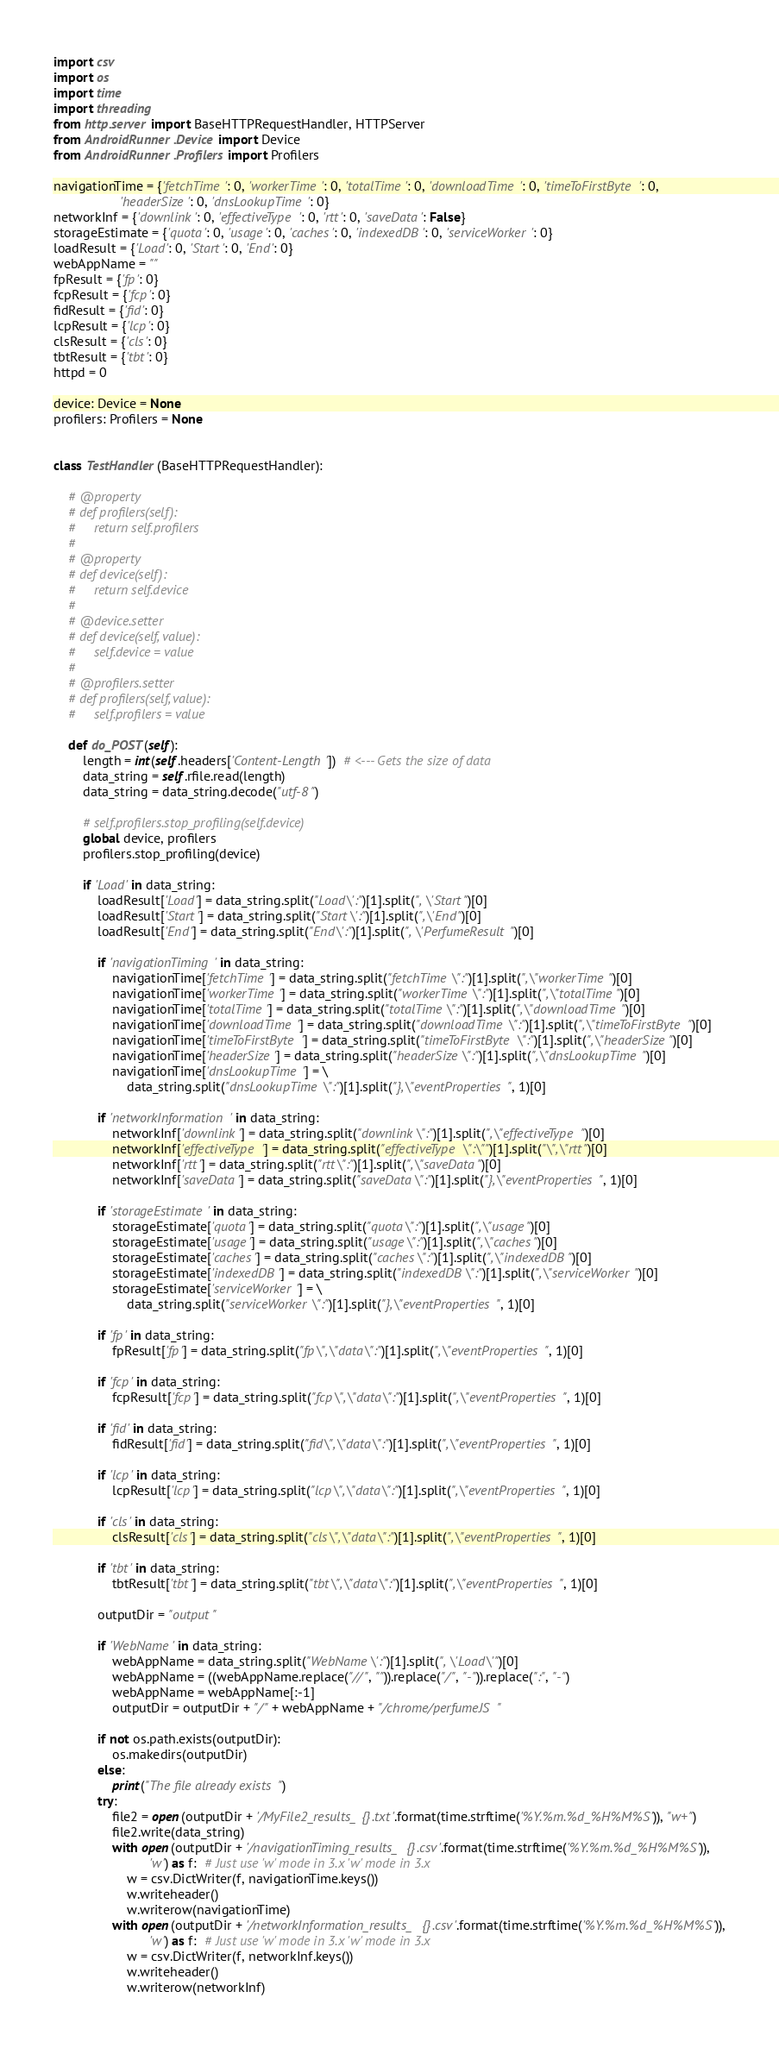Convert code to text. <code><loc_0><loc_0><loc_500><loc_500><_Python_>import csv
import os
import time
import threading
from http.server import BaseHTTPRequestHandler, HTTPServer
from AndroidRunner.Device import Device
from AndroidRunner.Profilers import Profilers

navigationTime = {'fetchTime': 0, 'workerTime': 0, 'totalTime': 0, 'downloadTime': 0, 'timeToFirstByte': 0,
                  'headerSize': 0, 'dnsLookupTime': 0}
networkInf = {'downlink': 0, 'effectiveType': 0, 'rtt': 0, 'saveData': False}
storageEstimate = {'quota': 0, 'usage': 0, 'caches': 0, 'indexedDB': 0, 'serviceWorker': 0}
loadResult = {'Load': 0, 'Start': 0, 'End': 0}
webAppName = ""
fpResult = {'fp': 0}
fcpResult = {'fcp': 0}
fidResult = {'fid': 0}
lcpResult = {'lcp': 0}
clsResult = {'cls': 0}
tbtResult = {'tbt': 0}
httpd = 0

device: Device = None
profilers: Profilers = None


class TestHandler(BaseHTTPRequestHandler):

    # @property
    # def profilers(self):
    #     return self.profilers
    #
    # @property
    # def device(self):
    #     return self.device
    #
    # @device.setter
    # def device(self, value):
    #     self.device = value
    #
    # @profilers.setter
    # def profilers(self, value):
    #     self.profilers = value

    def do_POST(self):
        length = int(self.headers['Content-Length'])  # <--- Gets the size of data
        data_string = self.rfile.read(length)
        data_string = data_string.decode("utf-8")

        # self.profilers.stop_profiling(self.device)
        global device, profilers
        profilers.stop_profiling(device)

        if 'Load' in data_string:
            loadResult['Load'] = data_string.split("Load\':")[1].split(", \'Start")[0]
            loadResult['Start'] = data_string.split("Start\':")[1].split(",\'End")[0]
            loadResult['End'] = data_string.split("End\':")[1].split(", \'PerfumeResult")[0]

            if 'navigationTiming' in data_string:
                navigationTime['fetchTime'] = data_string.split("fetchTime\":")[1].split(",\"workerTime")[0]
                navigationTime['workerTime'] = data_string.split("workerTime\":")[1].split(",\"totalTime")[0]
                navigationTime['totalTime'] = data_string.split("totalTime\":")[1].split(",\"downloadTime")[0]
                navigationTime['downloadTime'] = data_string.split("downloadTime\":")[1].split(",\"timeToFirstByte")[0]
                navigationTime['timeToFirstByte'] = data_string.split("timeToFirstByte\":")[1].split(",\"headerSize")[0]
                navigationTime['headerSize'] = data_string.split("headerSize\":")[1].split(",\"dnsLookupTime")[0]
                navigationTime['dnsLookupTime'] = \
                    data_string.split("dnsLookupTime\":")[1].split("},\"eventProperties", 1)[0]

            if 'networkInformation' in data_string:
                networkInf['downlink'] = data_string.split("downlink\":")[1].split(",\"effectiveType")[0]
                networkInf['effectiveType'] = data_string.split("effectiveType\":\"")[1].split("\",\"rtt")[0]
                networkInf['rtt'] = data_string.split("rtt\":")[1].split(",\"saveData")[0]
                networkInf['saveData'] = data_string.split("saveData\":")[1].split("},\"eventProperties", 1)[0]

            if 'storageEstimate' in data_string:
                storageEstimate['quota'] = data_string.split("quota\":")[1].split(",\"usage")[0]
                storageEstimate['usage'] = data_string.split("usage\":")[1].split(",\"caches")[0]
                storageEstimate['caches'] = data_string.split("caches\":")[1].split(",\"indexedDB")[0]
                storageEstimate['indexedDB'] = data_string.split("indexedDB\":")[1].split(",\"serviceWorker")[0]
                storageEstimate['serviceWorker'] = \
                    data_string.split("serviceWorker\":")[1].split("},\"eventProperties", 1)[0]

            if 'fp' in data_string:
                fpResult['fp'] = data_string.split("fp\",\"data\":")[1].split(",\"eventProperties", 1)[0]

            if 'fcp' in data_string:
                fcpResult['fcp'] = data_string.split("fcp\",\"data\":")[1].split(",\"eventProperties", 1)[0]

            if 'fid' in data_string:
                fidResult['fid'] = data_string.split("fid\",\"data\":")[1].split(",\"eventProperties", 1)[0]

            if 'lcp' in data_string:
                lcpResult['lcp'] = data_string.split("lcp\",\"data\":")[1].split(",\"eventProperties", 1)[0]

            if 'cls' in data_string:
                clsResult['cls'] = data_string.split("cls\",\"data\":")[1].split(",\"eventProperties", 1)[0]

            if 'tbt' in data_string:
                tbtResult['tbt'] = data_string.split("tbt\",\"data\":")[1].split(",\"eventProperties", 1)[0]

            outputDir = "output"

            if 'WebName' in data_string:
                webAppName = data_string.split("WebName\':")[1].split(", \'Load\'")[0]
                webAppName = ((webAppName.replace("//", "")).replace("/", "-")).replace(":", "-")
                webAppName = webAppName[:-1]
                outputDir = outputDir + "/" + webAppName + "/chrome/perfumeJS"

            if not os.path.exists(outputDir):
                os.makedirs(outputDir)
            else:
                print("The file already exists")
            try:
                file2 = open(outputDir + '/MyFile2_results_{}.txt'.format(time.strftime('%Y.%m.%d_%H%M%S')), "w+")
                file2.write(data_string)
                with open(outputDir + '/navigationTiming_results_{}.csv'.format(time.strftime('%Y.%m.%d_%H%M%S')),
                          'w') as f:  # Just use 'w' mode in 3.x 'w' mode in 3.x
                    w = csv.DictWriter(f, navigationTime.keys())
                    w.writeheader()
                    w.writerow(navigationTime)
                with open(outputDir + '/networkInformation_results_{}.csv'.format(time.strftime('%Y.%m.%d_%H%M%S')),
                          'w') as f:  # Just use 'w' mode in 3.x 'w' mode in 3.x
                    w = csv.DictWriter(f, networkInf.keys())
                    w.writeheader()
                    w.writerow(networkInf)</code> 